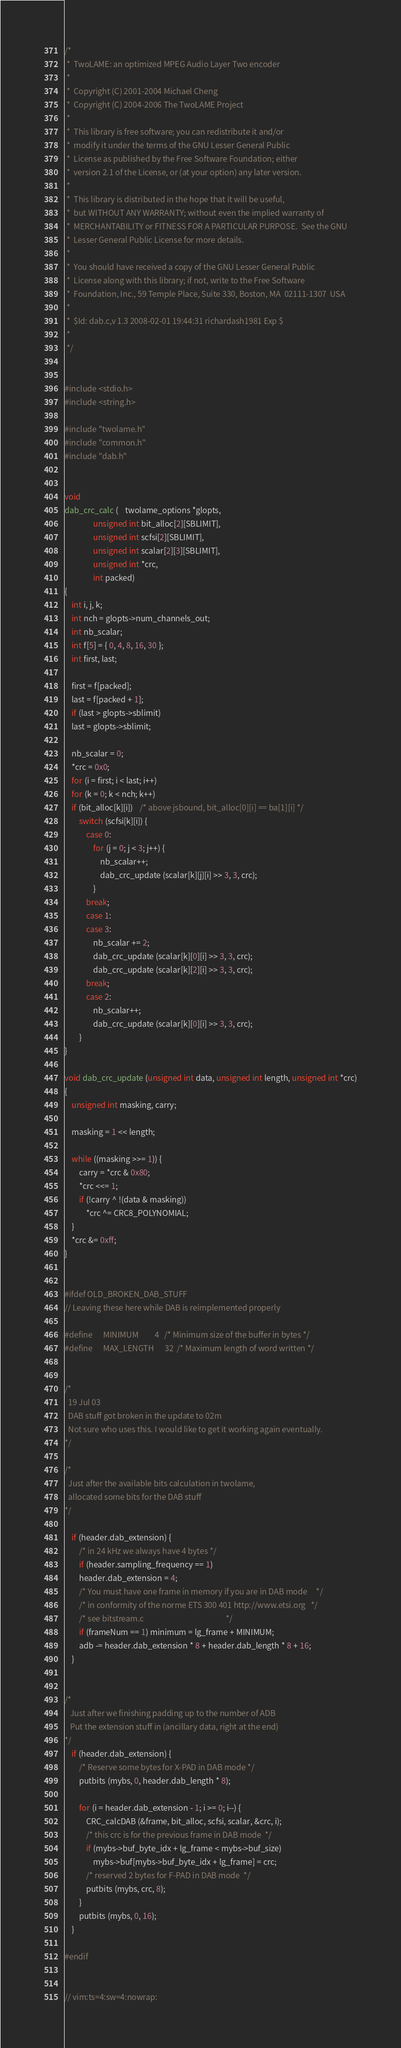Convert code to text. <code><loc_0><loc_0><loc_500><loc_500><_C_>/*
 *  TwoLAME: an optimized MPEG Audio Layer Two encoder
 *
 *  Copyright (C) 2001-2004 Michael Cheng
 *  Copyright (C) 2004-2006 The TwoLAME Project
 *
 *  This library is free software; you can redistribute it and/or
 *  modify it under the terms of the GNU Lesser General Public
 *  License as published by the Free Software Foundation; either
 *  version 2.1 of the License, or (at your option) any later version.
 *
 *  This library is distributed in the hope that it will be useful,
 *  but WITHOUT ANY WARRANTY; without even the implied warranty of
 *  MERCHANTABILITY or FITNESS FOR A PARTICULAR PURPOSE.  See the GNU
 *  Lesser General Public License for more details.
 *
 *  You should have received a copy of the GNU Lesser General Public
 *  License along with this library; if not, write to the Free Software
 *  Foundation, Inc., 59 Temple Place, Suite 330, Boston, MA  02111-1307  USA
 *
 *  $Id: dab.c,v 1.3 2008-02-01 19:44:31 richardash1981 Exp $
 *
 */


#include <stdio.h>
#include <string.h>

#include "twolame.h"
#include "common.h"
#include "dab.h"


void
dab_crc_calc (	twolame_options *glopts,
				unsigned int bit_alloc[2][SBLIMIT],
				unsigned int scfsi[2][SBLIMIT],
				unsigned int scalar[2][3][SBLIMIT], 
				unsigned int *crc,
				int packed)
{
	int i, j, k;
	int nch = glopts->num_channels_out;
	int nb_scalar;
	int f[5] = { 0, 4, 8, 16, 30 };
	int first, last;
	
	first = f[packed];
	last = f[packed + 1];
	if (last > glopts->sblimit)
	last = glopts->sblimit;
	
	nb_scalar = 0;
	*crc = 0x0;
	for (i = first; i < last; i++)
	for (k = 0; k < nch; k++)
	if (bit_alloc[k][i])	/* above jsbound, bit_alloc[0][i] == ba[1][i] */
		switch (scfsi[k][i]) {
			case 0:
				for (j = 0; j < 3; j++) {
					nb_scalar++;
					dab_crc_update (scalar[k][j][i] >> 3, 3, crc);
				}
			break;
			case 1:
			case 3:
				nb_scalar += 2;
				dab_crc_update (scalar[k][0][i] >> 3, 3, crc);
				dab_crc_update (scalar[k][2][i] >> 3, 3, crc);
			break;
			case 2:
				nb_scalar++;
				dab_crc_update (scalar[k][0][i] >> 3, 3, crc);
		}
}

void dab_crc_update (unsigned int data, unsigned int length, unsigned int *crc)
{
	unsigned int masking, carry;
	
	masking = 1 << length;
	
	while ((masking >>= 1)) {
		carry = *crc & 0x80;
		*crc <<= 1;
		if (!carry ^ !(data & masking))
			*crc ^= CRC8_POLYNOMIAL;
	}
	*crc &= 0xff;
}


#ifdef OLD_BROKEN_DAB_STUFF
// Leaving these here while DAB is reimplemented properly

#define		MINIMUM			4   /* Minimum size of the buffer in bytes */
#define		MAX_LENGTH		32  /* Maximum length of word written */


/*
  19 Jul 03
  DAB stuff got broken in the update to 02m
  Not sure who uses this. I would like to get it working again eventually.
*/

/*
  Just after the available bits calculation in twolame, 
  allocated some bits for the DAB stuff 
*/

	if (header.dab_extension) {
		/* in 24 kHz we always have 4 bytes */
		if (header.sampling_frequency == 1)
		header.dab_extension = 4;
		/* You must have one frame in memory if you are in DAB mode		*/
		/* in conformity of the norme ETS 300 401 http://www.etsi.org	*/
		/* see bitstream.c												*/
		if (frameNum == 1) minimum = lg_frame + MINIMUM;
		adb -= header.dab_extension * 8 + header.dab_length * 8 + 16;
	}


/* 
   Just after we finishing padding up to the number of ADB
   Put the extension stuff in (ancillary data, right at the end)
*/
	if (header.dab_extension) {
		/* Reserve some bytes for X-PAD in DAB mode */
		putbits (mybs, 0, header.dab_length * 8);
		
		for (i = header.dab_extension - 1; i >= 0; i--) {
			CRC_calcDAB (&frame, bit_alloc, scfsi, scalar, &crc, i);
			/* this crc is for the previous frame in DAB mode  */
			if (mybs->buf_byte_idx + lg_frame < mybs->buf_size)
				mybs->buf[mybs->buf_byte_idx + lg_frame] = crc;
			/* reserved 2 bytes for F-PAD in DAB mode  */
			putbits (mybs, crc, 8);
		}
		putbits (mybs, 0, 16);
	}

#endif


// vim:ts=4:sw=4:nowrap: 

</code> 